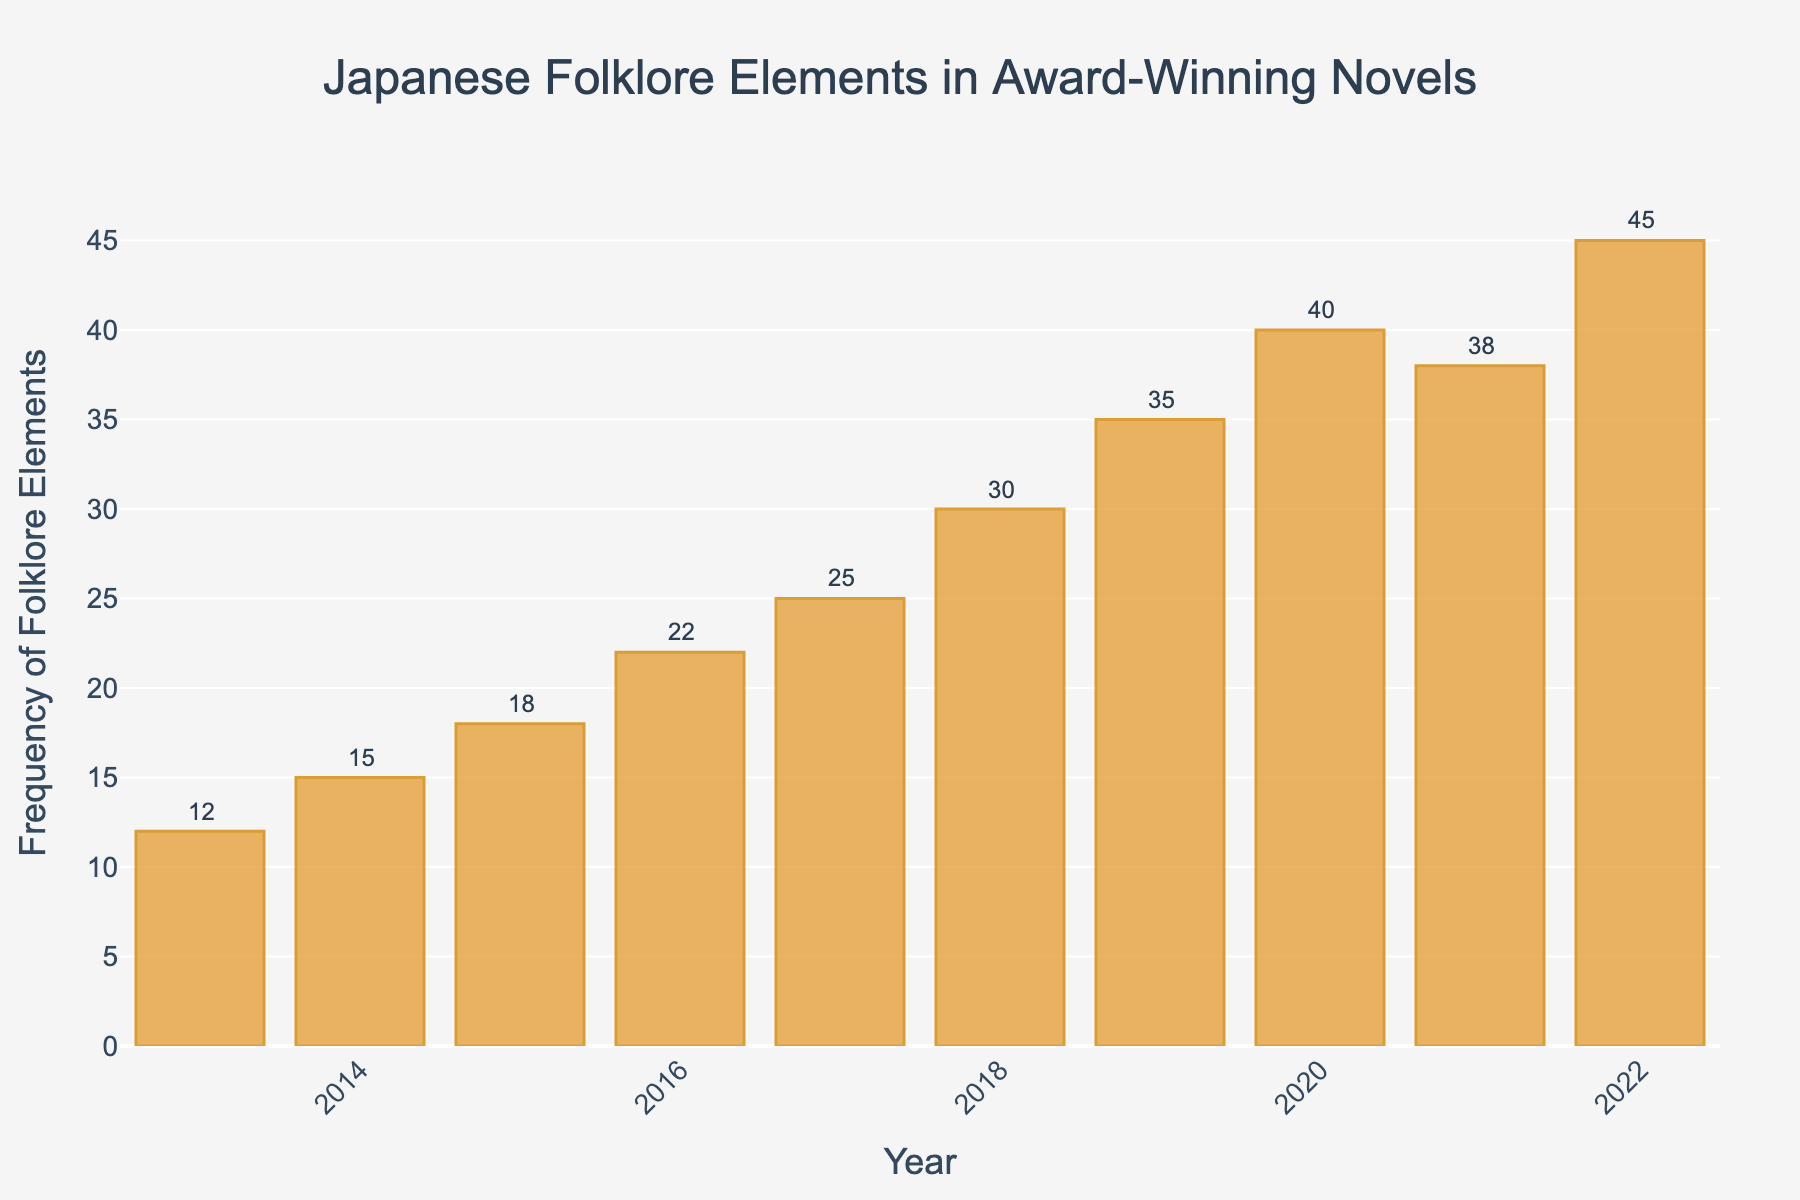What trend do you observe in the frequency of Japanese folklore elements in award-winning novels from 2013 to 2022? The bar chart shows a generally increasing trend in the frequency of Japanese folklore elements from 2013 to 2022. The frequency starts at 12 in 2013 and reaches its highest at 45 in 2022, with only minor fluctuations in 2020 and 2021.
Answer: Increasing trend Which year had the highest frequency of Japanese folklore elements in award-winning novels? By looking at the heights of the bars, the year 2022 has the highest bar, indicating the highest frequency of 45 Japanese folklore elements.
Answer: 2022 By how much did the frequency of folklore elements increase from 2013 to 2022? The frequency was 12 in 2013 and 45 in 2022. The increase is calculated as 45 - 12 = 33.
Answer: 33 In which year did the frequency of Japanese folklore elements first exceed 30? By observing the heights of the bars, 2018 is the first year that the bar reaches beyond the 30-mark.
Answer: 2018 What is the average frequency of Japanese folklore elements over the observed years? Sum up the frequencies from 2013 to 2022 (12 + 15 + 18 + 22 + 25 + 30 + 35 + 40 + 38 + 45 = 280). There are 10 years. Divide the total by 10: 280 / 10 = 28.
Answer: 28 How many times did the frequency of Japanese folklore elements decline compared to the previous year? Comparing each year to the preceding year, declines occurred in 2021 compared to 2020 (40 to 38). This means a single occurrence of decline.
Answer: 1 Which two consecutive years had the highest increase in folklore elements frequency, and what was the increase? By comparing the differences:
- 2014-2013: 15 - 12 = 3
- 2015-2014: 18 - 15 = 3
- 2016-2015: 22 - 18 = 4
- 2017-2016: 25 - 22 = 3
- 2018-2017: 30 - 25 = 5
- 2019-2018: 35 - 30 = 5
- 2020-2019: 40 - 35 = 5
- 2021-2020: 38 - 40 = -2
- 2022-2021: 45 - 38 = 7
The highest increase is between 2021 and 2022, with an increase of 7.
Answer: 2021 to 2022, 7 How does the frequency in 2016 compare to the frequency in 2014? The frequency in 2016 is 22, while in 2014 it is 15. Therefore, 22 is greater than 15.
Answer: 2016 greater What is the median value of the frequencies from 2013 to 2022? Listing the frequencies in ascending order: 12, 15, 18, 22, 25, 30, 35, 38, 40, 45. The median value in an even-numbered list is the average of the 5th and 6th values: (25 + 30) / 2 = 27.5
Answer: 27.5 